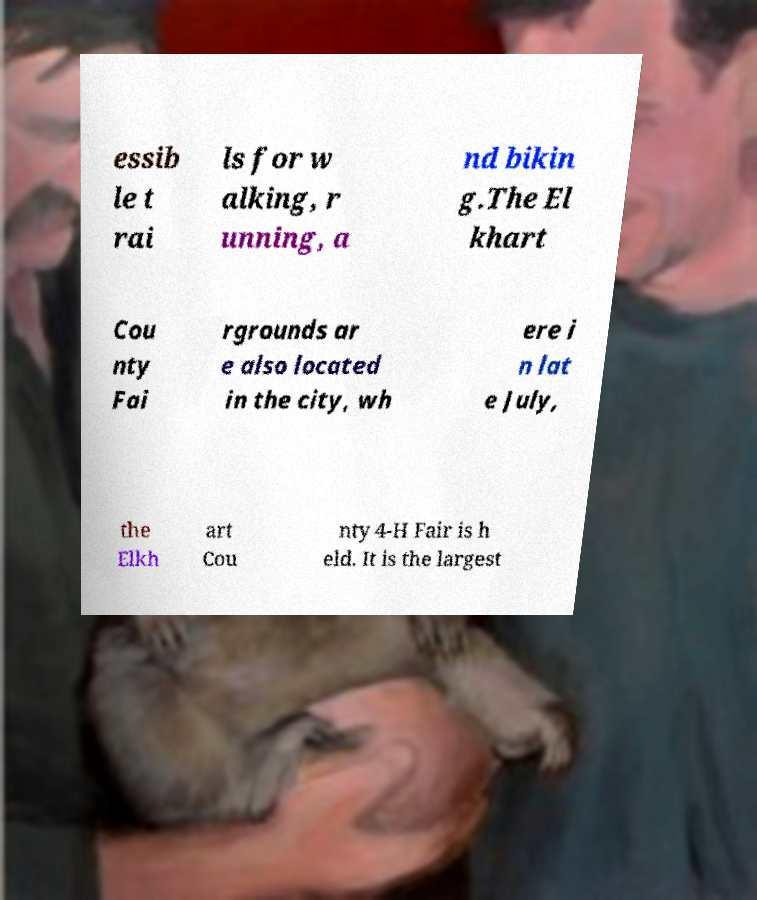Please identify and transcribe the text found in this image. essib le t rai ls for w alking, r unning, a nd bikin g.The El khart Cou nty Fai rgrounds ar e also located in the city, wh ere i n lat e July, the Elkh art Cou nty 4-H Fair is h eld. It is the largest 